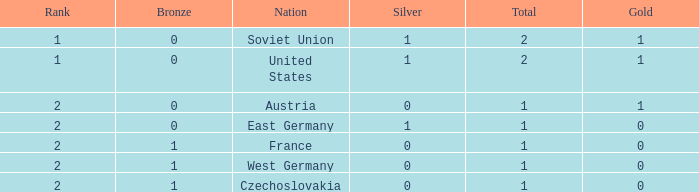What is the rank of the team with 0 gold and less than 0 silvers? None. 